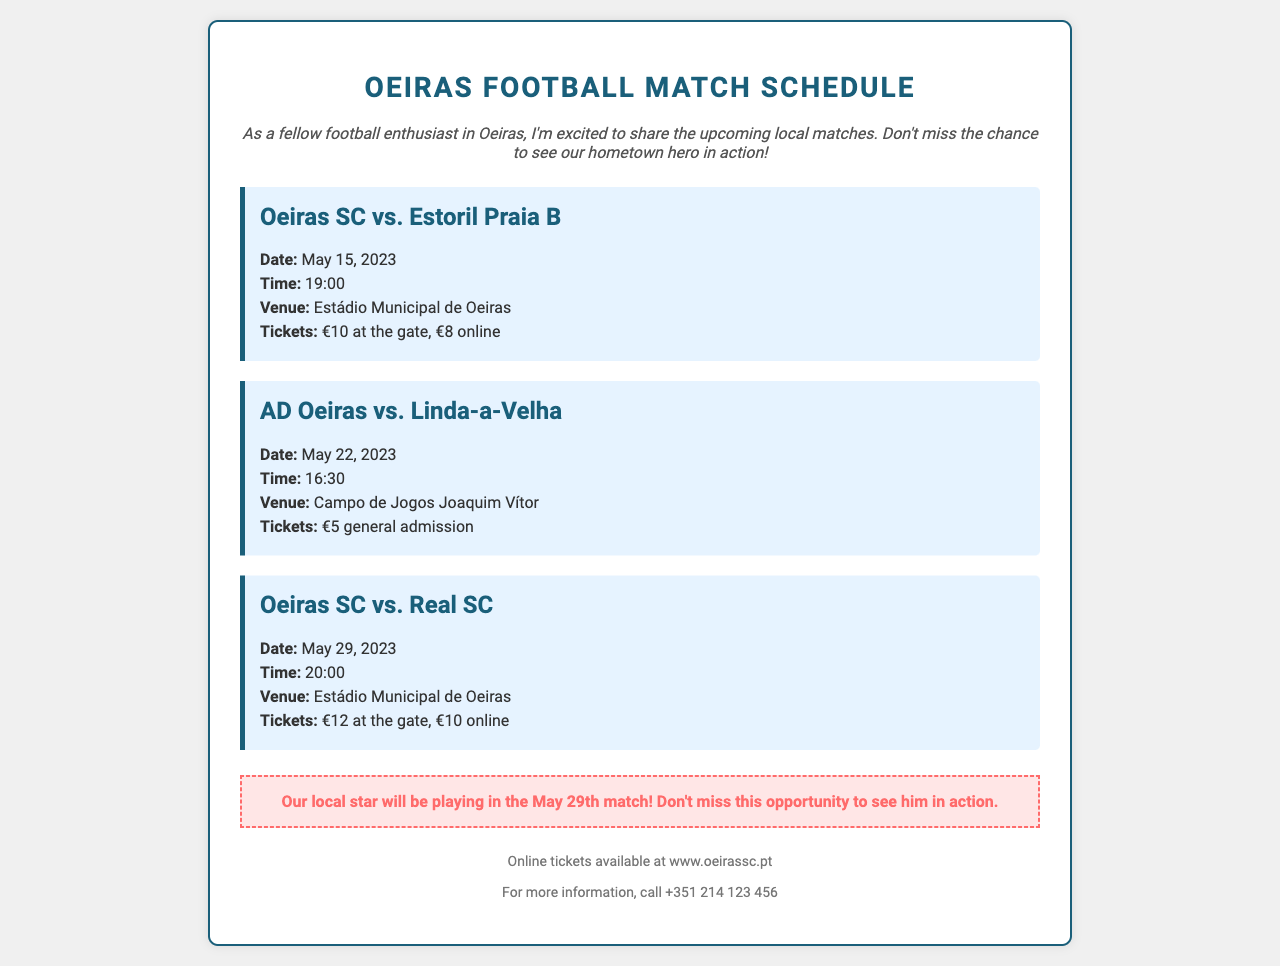What is the date of the match between Oeiras SC and Estoril Praia B? The date of the match is specifically mentioned in the document, which is May 15, 2023.
Answer: May 15, 2023 What time does the match against Linda-a-Velha start? The time for the match against Linda-a-Velha is specified in the document as 16:30.
Answer: 16:30 How much is a ticket for the match on May 29th when bought online? The ticket price for online purchases for the May 29th match is mentioned as €10.
Answer: €10 What is the venue for the match between AD Oeiras and Linda-a-Velha? The venue for this match is listed in the document, which is Campo de Jogos Joaquim Vítor.
Answer: Campo de Jogos Joaquim Vítor In which match will the local star be playing? According to the special note, the local star will be playing in the match on May 29th.
Answer: May 29th match What is the ticket price for the Oeiras SC vs. Real SC match at the gate? The gate ticket price for this match is provided in the document as €12.
Answer: €12 Where can online tickets be purchased? The document specifies the website for purchasing online tickets as www.oeirassc.pt.
Answer: www.oeirassc.pt What is the contact number for more information? The document includes a contact number for inquiries, which is +351 214 123 456.
Answer: +351 214 123 456 